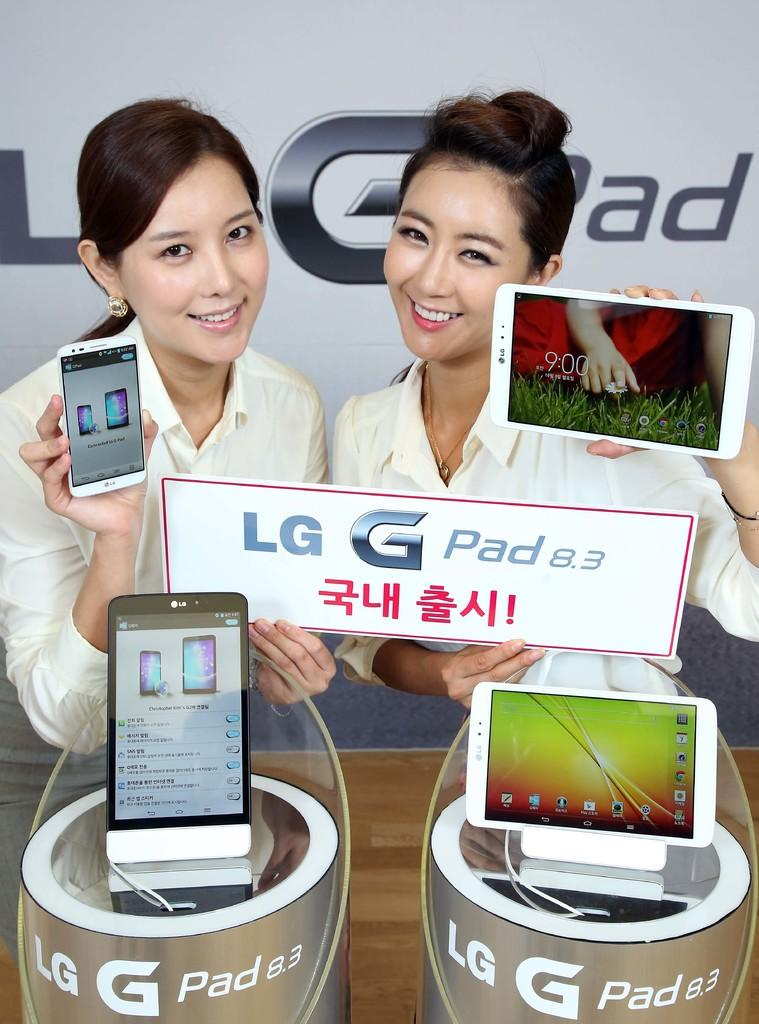<image>
Give a short and clear explanation of the subsequent image. Two women holding LG G pads in their hands as they stand by a display for LG 